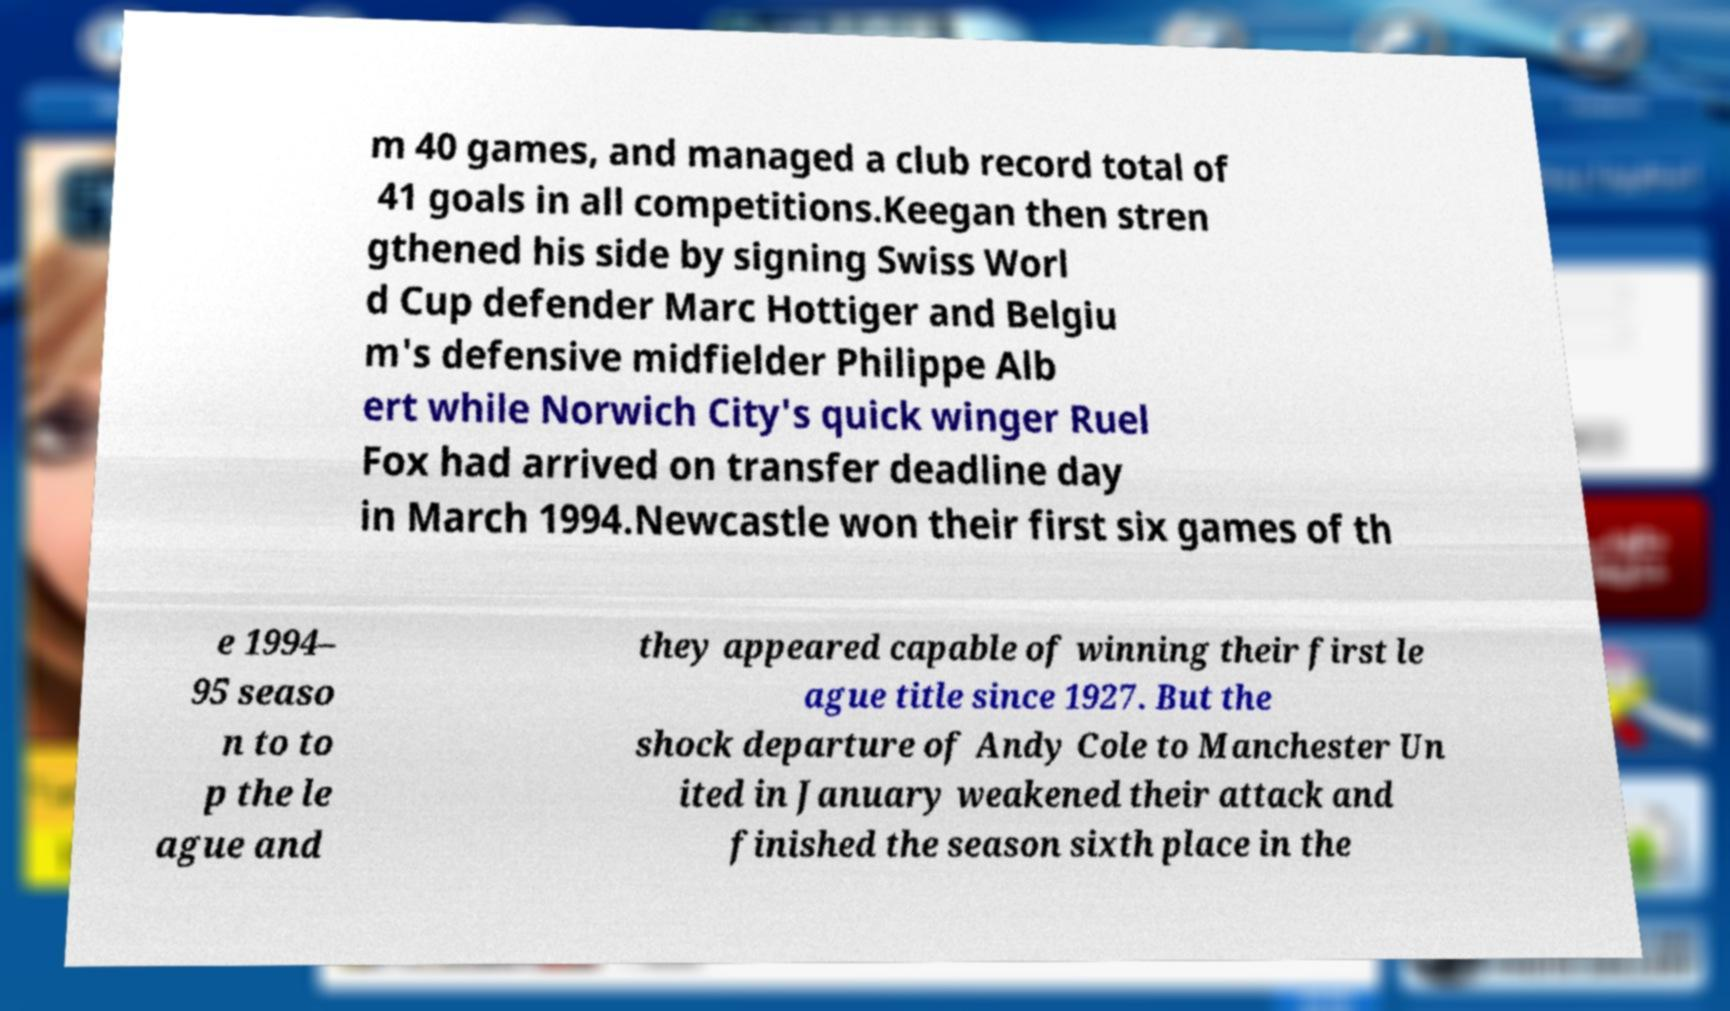I need the written content from this picture converted into text. Can you do that? m 40 games, and managed a club record total of 41 goals in all competitions.Keegan then stren gthened his side by signing Swiss Worl d Cup defender Marc Hottiger and Belgiu m's defensive midfielder Philippe Alb ert while Norwich City's quick winger Ruel Fox had arrived on transfer deadline day in March 1994.Newcastle won their first six games of th e 1994– 95 seaso n to to p the le ague and they appeared capable of winning their first le ague title since 1927. But the shock departure of Andy Cole to Manchester Un ited in January weakened their attack and finished the season sixth place in the 